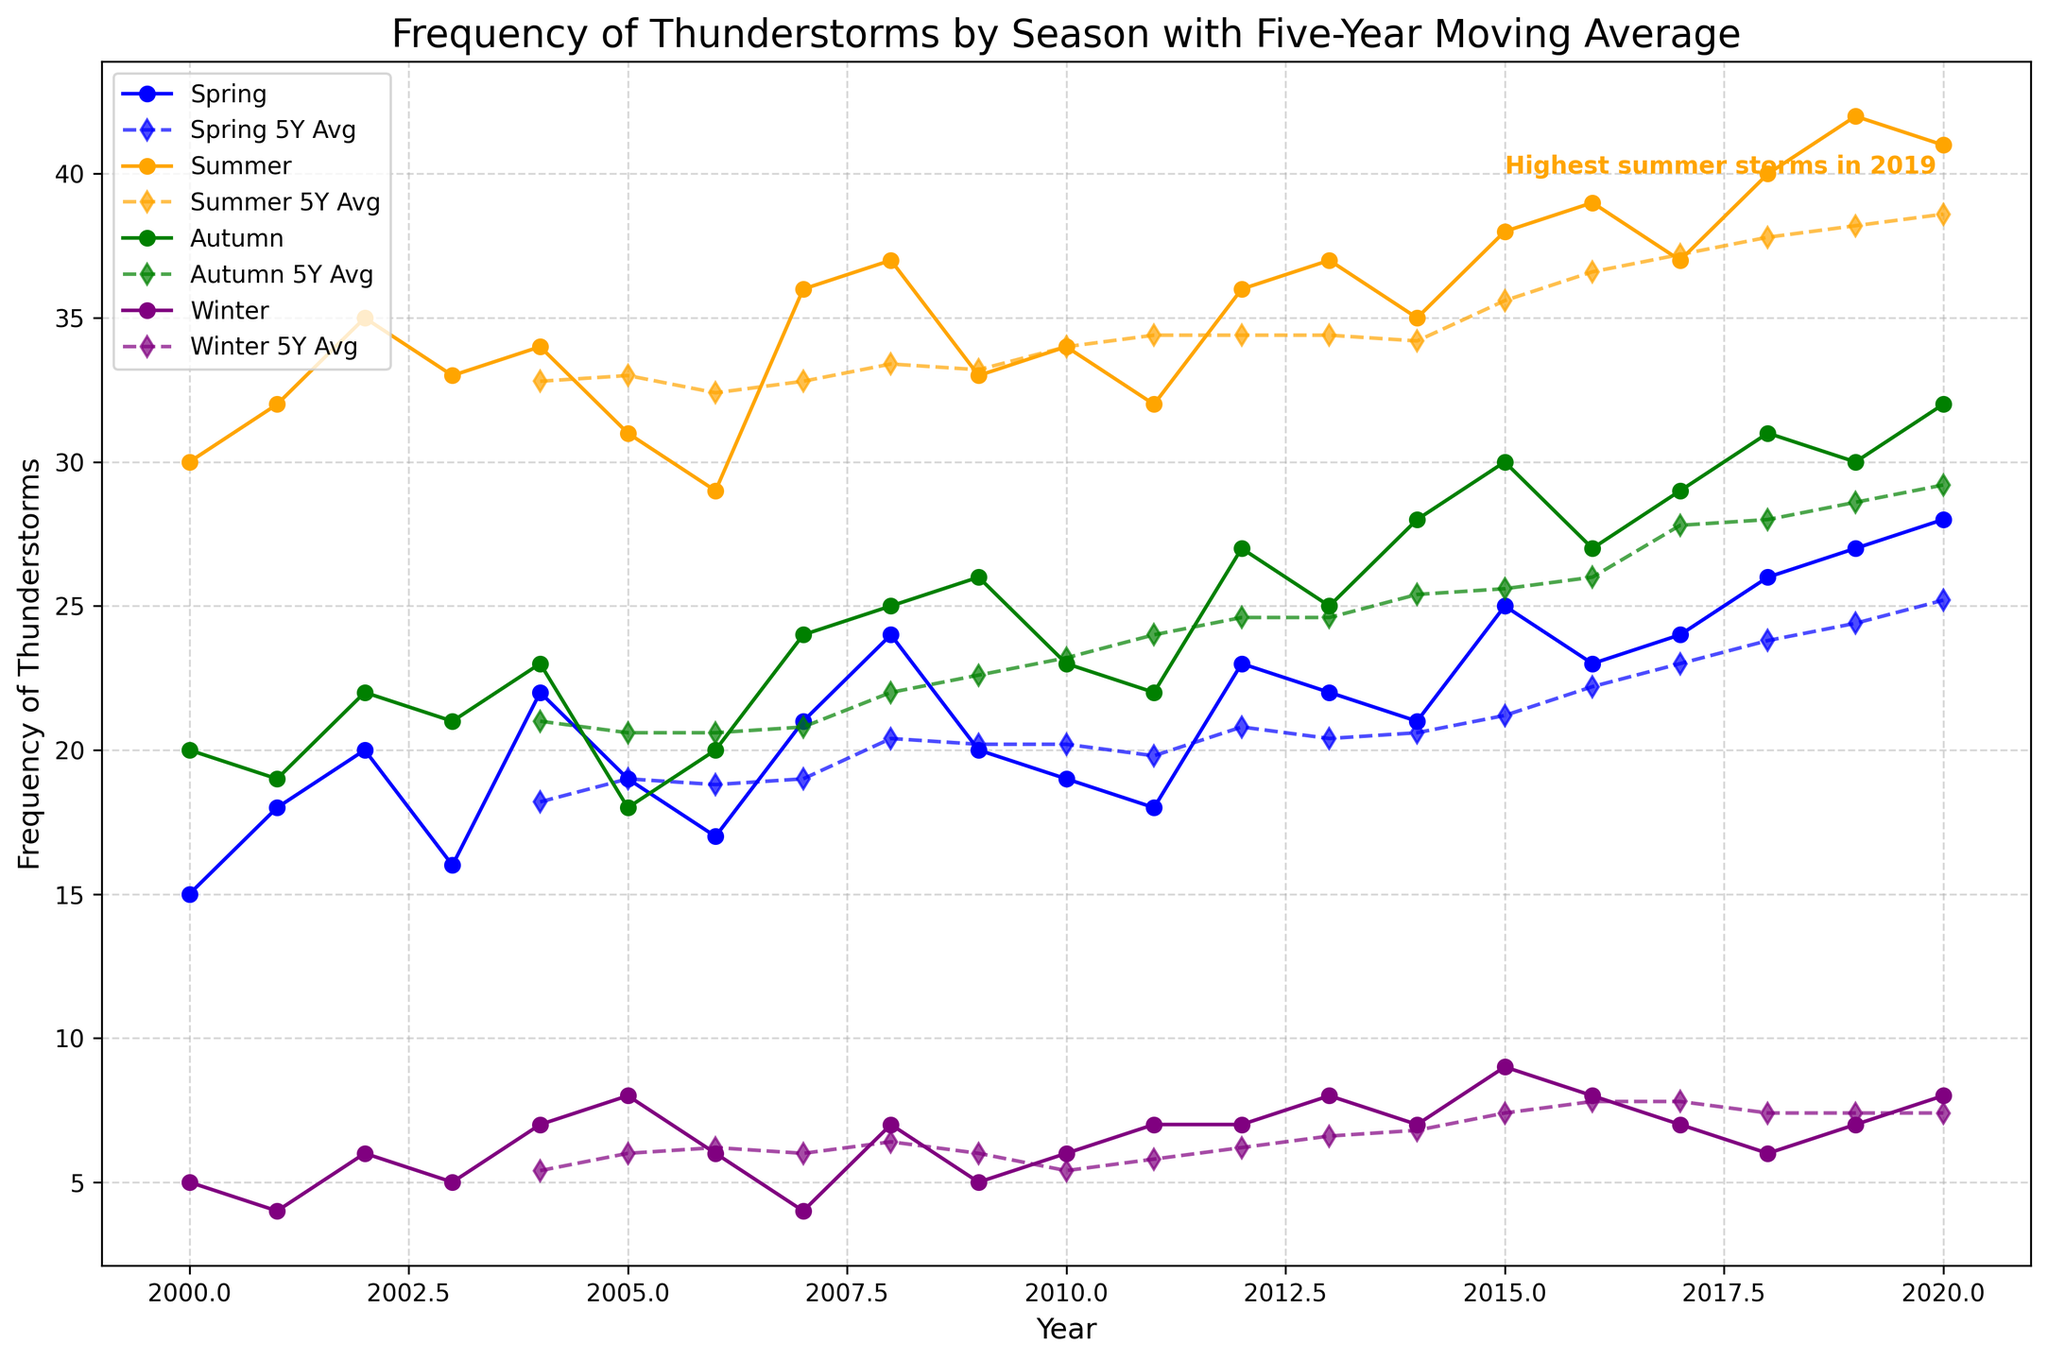What is the highest frequency of thunderstorms for Summer? The highest frequency of thunderstorms in the Summer can be identified by looking at the peak point of the orange line representing Summer thunderstorms. This peak occurs in 2019.
Answer: 42 Which season had the highest number of thunderstorms in the year 2004? To answer this, compare each season's thunderstorm frequency for 2004. Spring had 22, Summer had 34, Autumn had 23, and Winter had 7.
Answer: Summer From 2015 to 2020, which season shows the most significant increase in the five-year moving average? Compare the 5Y moving averages for each season from 2015 to 2020. For Spring, it increased from 21.2 to 25.2, Summer from 35.6 to 38.6, Autumn from 25.6 to 29.2, and Winter from 7.4 to 7.4. The increase is highest for Autumn.
Answer: Autumn How many years did the frequency of winter thunderstorms exactly match its 5Y moving average? Identify the years when the purple dashed line (Winter 5Y Avg) and the purple solid line (Winter) are at the same level. This happened in 2008, 2011, 2014, and 2018.
Answer: 4 What is the trend observed in Summer thunderstorms from 2000 to 2020? Observe the orange line marking summer thunderstorm frequencies. The trend shows a general increase, reaching the highest value of 42 in 2019 before slightly decreasing.
Answer: Increasing trend What annotation is included in the plot and what does it signify? An orange text annotation near 2015 signifies "Highest summer storms in 2019," indicating that 2019 had the highest recorded thunderstorms in Summer.
Answer: Highest summer storms in 2019 Which season had the least variation in the frequency of thunderstorms over the years? To determine this, compare the spread of data points for each season. Winter shows the least variation as its values are between 4 and 9.
Answer: Winter In which years did Spring thunderstorms match or exceed 25 frequencies? Identify the years when the blue line representing Spring thunderstorms is at or above the 25 mark. This happened in 2018, 2019, 2020.
Answer: 3 years: 2018, 2019, 2020 How does the frequency of Autumn thunderstorms in 2020 compare to its five-year moving average? Compare the green line (Autumn) and the green dashed line (Autumn 5Y Avg) in 2020. The actual frequency is 32 whereas the 5Y moving average is 29.2.
Answer: Higher 